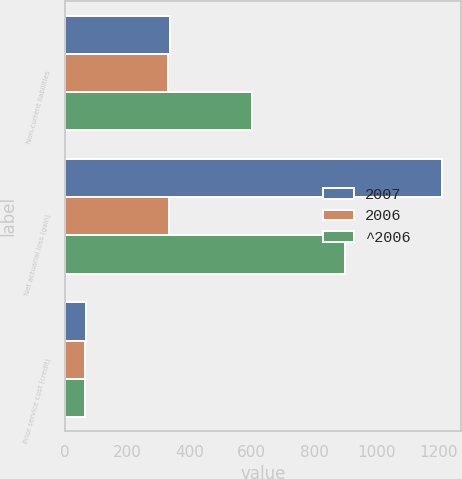Convert chart. <chart><loc_0><loc_0><loc_500><loc_500><stacked_bar_chart><ecel><fcel>Non-current liabilities<fcel>Net actuarial loss (gain)<fcel>Prior service cost (credit)<nl><fcel>2007<fcel>338<fcel>1210<fcel>68<nl><fcel>2006<fcel>332<fcel>335<fcel>64<nl><fcel>^2006<fcel>601<fcel>899<fcel>65<nl></chart> 